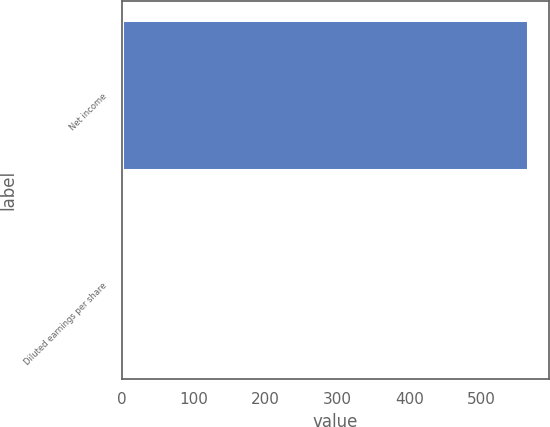Convert chart. <chart><loc_0><loc_0><loc_500><loc_500><bar_chart><fcel>Net income<fcel>Diluted earnings per share<nl><fcel>566<fcel>6.45<nl></chart> 